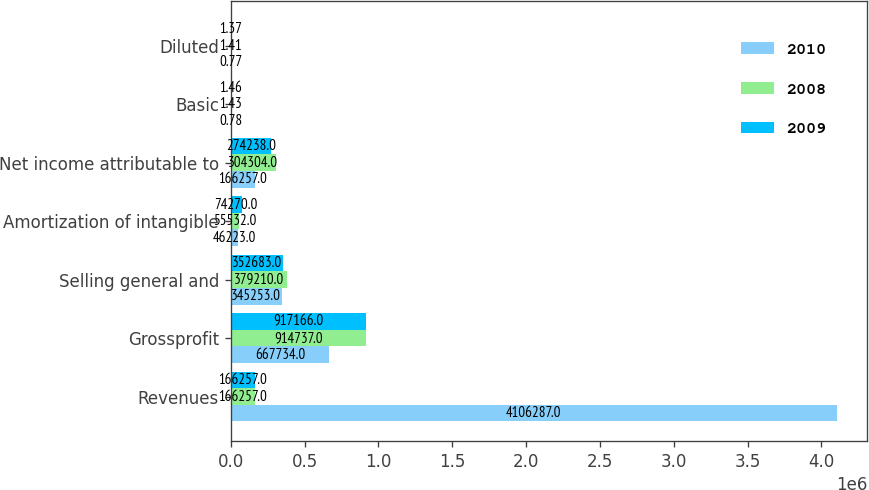Convert chart. <chart><loc_0><loc_0><loc_500><loc_500><stacked_bar_chart><ecel><fcel>Revenues<fcel>Grossprofit<fcel>Selling general and<fcel>Amortization of intangible<fcel>Net income attributable to<fcel>Basic<fcel>Diluted<nl><fcel>2010<fcel>4.10629e+06<fcel>667734<fcel>345253<fcel>46223<fcel>166257<fcel>0.78<fcel>0.77<nl><fcel>2008<fcel>166257<fcel>914737<fcel>379210<fcel>55532<fcel>304304<fcel>1.43<fcel>1.41<nl><fcel>2009<fcel>166257<fcel>917166<fcel>352683<fcel>74270<fcel>274238<fcel>1.46<fcel>1.37<nl></chart> 